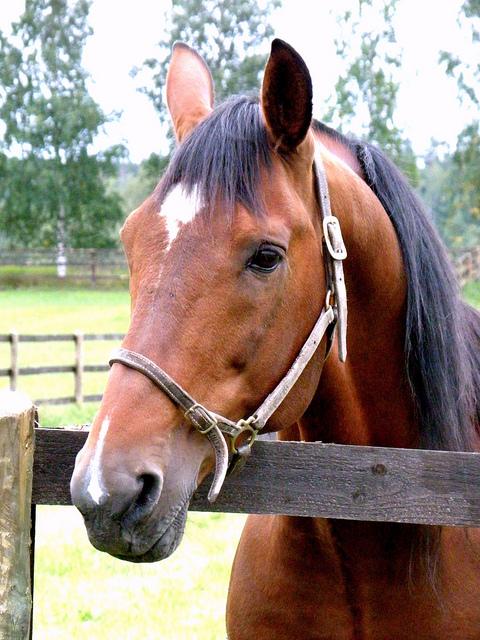What does the horse have on his head?
Be succinct. Bridle. How long is that strip of white?
Answer briefly. 6 inches. How many horses are there?
Quick response, please. 1. What color is the horse's mane?
Be succinct. Black. 